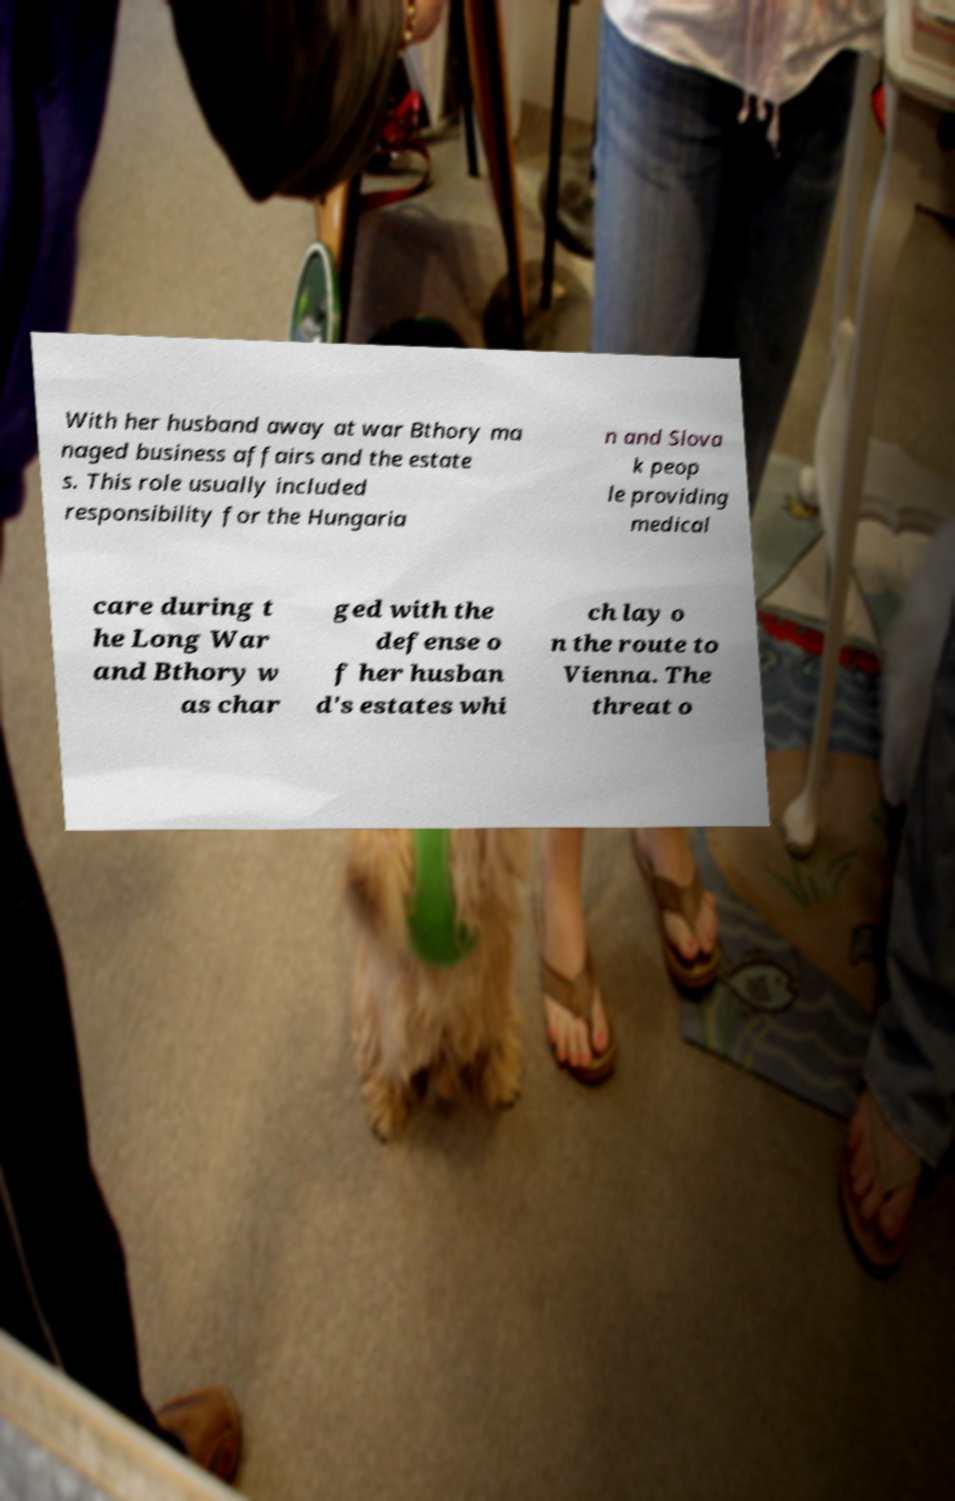What messages or text are displayed in this image? I need them in a readable, typed format. With her husband away at war Bthory ma naged business affairs and the estate s. This role usually included responsibility for the Hungaria n and Slova k peop le providing medical care during t he Long War and Bthory w as char ged with the defense o f her husban d's estates whi ch lay o n the route to Vienna. The threat o 